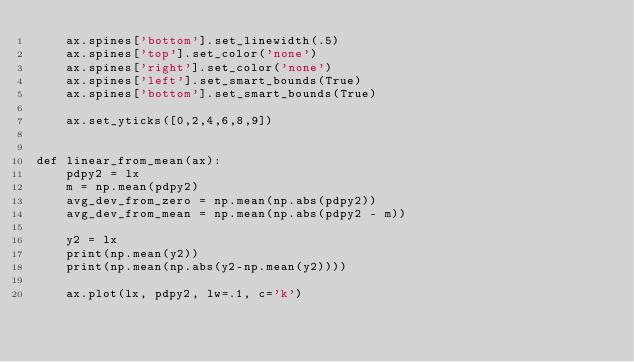Convert code to text. <code><loc_0><loc_0><loc_500><loc_500><_Python_>    ax.spines['bottom'].set_linewidth(.5)
    ax.spines['top'].set_color('none')
    ax.spines['right'].set_color('none')
    ax.spines['left'].set_smart_bounds(True)
    ax.spines['bottom'].set_smart_bounds(True)

    ax.set_yticks([0,2,4,6,8,9])


def linear_from_mean(ax):
    pdpy2 = lx
    m = np.mean(pdpy2)
    avg_dev_from_zero = np.mean(np.abs(pdpy2))
    avg_dev_from_mean = np.mean(np.abs(pdpy2 - m))

    y2 = lx
    print(np.mean(y2))
    print(np.mean(np.abs(y2-np.mean(y2))))

    ax.plot(lx, pdpy2, lw=.1, c='k')
</code> 